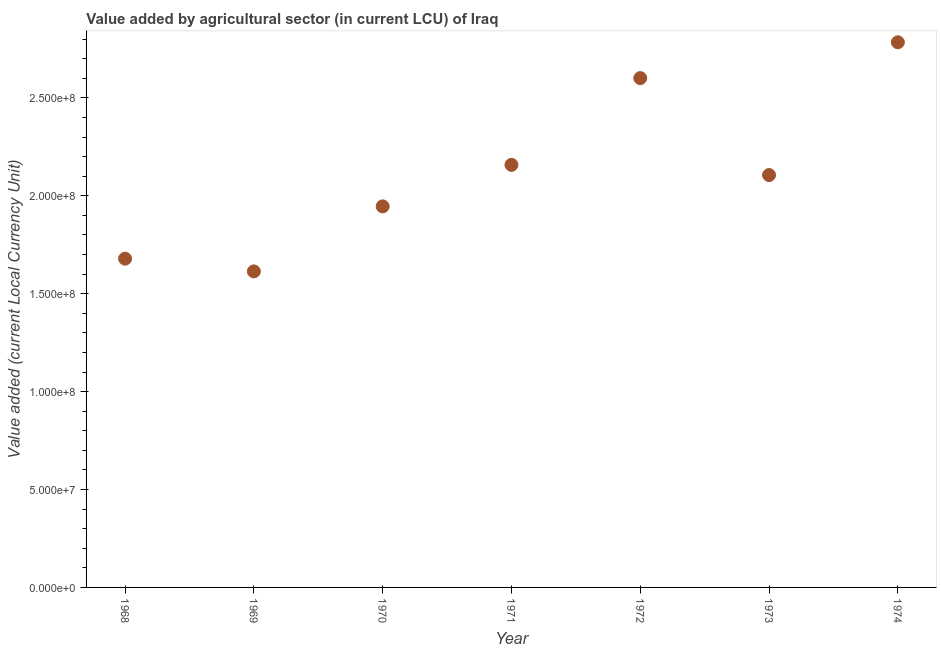What is the value added by agriculture sector in 1971?
Make the answer very short. 2.16e+08. Across all years, what is the maximum value added by agriculture sector?
Offer a terse response. 2.78e+08. Across all years, what is the minimum value added by agriculture sector?
Provide a short and direct response. 1.61e+08. In which year was the value added by agriculture sector maximum?
Provide a short and direct response. 1974. In which year was the value added by agriculture sector minimum?
Offer a very short reply. 1969. What is the sum of the value added by agriculture sector?
Your response must be concise. 1.49e+09. What is the difference between the value added by agriculture sector in 1970 and 1974?
Keep it short and to the point. -8.38e+07. What is the average value added by agriculture sector per year?
Offer a very short reply. 2.13e+08. What is the median value added by agriculture sector?
Give a very brief answer. 2.11e+08. Do a majority of the years between 1971 and 1974 (inclusive) have value added by agriculture sector greater than 270000000 LCU?
Ensure brevity in your answer.  No. What is the ratio of the value added by agriculture sector in 1969 to that in 1971?
Provide a succinct answer. 0.75. Is the value added by agriculture sector in 1968 less than that in 1974?
Make the answer very short. Yes. Is the difference between the value added by agriculture sector in 1970 and 1973 greater than the difference between any two years?
Provide a short and direct response. No. What is the difference between the highest and the second highest value added by agriculture sector?
Give a very brief answer. 1.83e+07. Is the sum of the value added by agriculture sector in 1970 and 1971 greater than the maximum value added by agriculture sector across all years?
Offer a very short reply. Yes. What is the difference between the highest and the lowest value added by agriculture sector?
Your answer should be compact. 1.17e+08. How many dotlines are there?
Make the answer very short. 1. What is the difference between two consecutive major ticks on the Y-axis?
Give a very brief answer. 5.00e+07. Are the values on the major ticks of Y-axis written in scientific E-notation?
Keep it short and to the point. Yes. Does the graph contain grids?
Your response must be concise. No. What is the title of the graph?
Offer a very short reply. Value added by agricultural sector (in current LCU) of Iraq. What is the label or title of the X-axis?
Your answer should be very brief. Year. What is the label or title of the Y-axis?
Your answer should be very brief. Value added (current Local Currency Unit). What is the Value added (current Local Currency Unit) in 1968?
Keep it short and to the point. 1.68e+08. What is the Value added (current Local Currency Unit) in 1969?
Make the answer very short. 1.61e+08. What is the Value added (current Local Currency Unit) in 1970?
Give a very brief answer. 1.95e+08. What is the Value added (current Local Currency Unit) in 1971?
Keep it short and to the point. 2.16e+08. What is the Value added (current Local Currency Unit) in 1972?
Make the answer very short. 2.60e+08. What is the Value added (current Local Currency Unit) in 1973?
Ensure brevity in your answer.  2.11e+08. What is the Value added (current Local Currency Unit) in 1974?
Provide a short and direct response. 2.78e+08. What is the difference between the Value added (current Local Currency Unit) in 1968 and 1969?
Offer a very short reply. 6.50e+06. What is the difference between the Value added (current Local Currency Unit) in 1968 and 1970?
Keep it short and to the point. -2.67e+07. What is the difference between the Value added (current Local Currency Unit) in 1968 and 1971?
Your answer should be very brief. -4.79e+07. What is the difference between the Value added (current Local Currency Unit) in 1968 and 1972?
Offer a terse response. -9.22e+07. What is the difference between the Value added (current Local Currency Unit) in 1968 and 1973?
Give a very brief answer. -4.27e+07. What is the difference between the Value added (current Local Currency Unit) in 1968 and 1974?
Give a very brief answer. -1.10e+08. What is the difference between the Value added (current Local Currency Unit) in 1969 and 1970?
Offer a very short reply. -3.32e+07. What is the difference between the Value added (current Local Currency Unit) in 1969 and 1971?
Provide a succinct answer. -5.44e+07. What is the difference between the Value added (current Local Currency Unit) in 1969 and 1972?
Your answer should be compact. -9.87e+07. What is the difference between the Value added (current Local Currency Unit) in 1969 and 1973?
Give a very brief answer. -4.92e+07. What is the difference between the Value added (current Local Currency Unit) in 1969 and 1974?
Make the answer very short. -1.17e+08. What is the difference between the Value added (current Local Currency Unit) in 1970 and 1971?
Ensure brevity in your answer.  -2.12e+07. What is the difference between the Value added (current Local Currency Unit) in 1970 and 1972?
Your answer should be very brief. -6.55e+07. What is the difference between the Value added (current Local Currency Unit) in 1970 and 1973?
Provide a short and direct response. -1.60e+07. What is the difference between the Value added (current Local Currency Unit) in 1970 and 1974?
Offer a very short reply. -8.38e+07. What is the difference between the Value added (current Local Currency Unit) in 1971 and 1972?
Offer a very short reply. -4.43e+07. What is the difference between the Value added (current Local Currency Unit) in 1971 and 1973?
Your response must be concise. 5.20e+06. What is the difference between the Value added (current Local Currency Unit) in 1971 and 1974?
Give a very brief answer. -6.26e+07. What is the difference between the Value added (current Local Currency Unit) in 1972 and 1973?
Provide a short and direct response. 4.95e+07. What is the difference between the Value added (current Local Currency Unit) in 1972 and 1974?
Make the answer very short. -1.83e+07. What is the difference between the Value added (current Local Currency Unit) in 1973 and 1974?
Offer a terse response. -6.78e+07. What is the ratio of the Value added (current Local Currency Unit) in 1968 to that in 1969?
Keep it short and to the point. 1.04. What is the ratio of the Value added (current Local Currency Unit) in 1968 to that in 1970?
Your answer should be very brief. 0.86. What is the ratio of the Value added (current Local Currency Unit) in 1968 to that in 1971?
Your answer should be very brief. 0.78. What is the ratio of the Value added (current Local Currency Unit) in 1968 to that in 1972?
Provide a short and direct response. 0.65. What is the ratio of the Value added (current Local Currency Unit) in 1968 to that in 1973?
Give a very brief answer. 0.8. What is the ratio of the Value added (current Local Currency Unit) in 1968 to that in 1974?
Make the answer very short. 0.6. What is the ratio of the Value added (current Local Currency Unit) in 1969 to that in 1970?
Keep it short and to the point. 0.83. What is the ratio of the Value added (current Local Currency Unit) in 1969 to that in 1971?
Make the answer very short. 0.75. What is the ratio of the Value added (current Local Currency Unit) in 1969 to that in 1972?
Give a very brief answer. 0.62. What is the ratio of the Value added (current Local Currency Unit) in 1969 to that in 1973?
Your answer should be compact. 0.77. What is the ratio of the Value added (current Local Currency Unit) in 1969 to that in 1974?
Provide a succinct answer. 0.58. What is the ratio of the Value added (current Local Currency Unit) in 1970 to that in 1971?
Give a very brief answer. 0.9. What is the ratio of the Value added (current Local Currency Unit) in 1970 to that in 1972?
Offer a terse response. 0.75. What is the ratio of the Value added (current Local Currency Unit) in 1970 to that in 1973?
Your answer should be compact. 0.92. What is the ratio of the Value added (current Local Currency Unit) in 1970 to that in 1974?
Provide a short and direct response. 0.7. What is the ratio of the Value added (current Local Currency Unit) in 1971 to that in 1972?
Provide a short and direct response. 0.83. What is the ratio of the Value added (current Local Currency Unit) in 1971 to that in 1973?
Make the answer very short. 1.02. What is the ratio of the Value added (current Local Currency Unit) in 1971 to that in 1974?
Make the answer very short. 0.78. What is the ratio of the Value added (current Local Currency Unit) in 1972 to that in 1973?
Offer a terse response. 1.24. What is the ratio of the Value added (current Local Currency Unit) in 1972 to that in 1974?
Your response must be concise. 0.93. What is the ratio of the Value added (current Local Currency Unit) in 1973 to that in 1974?
Offer a terse response. 0.76. 